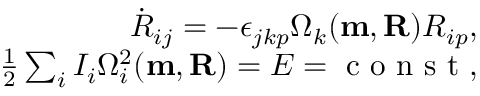Convert formula to latex. <formula><loc_0><loc_0><loc_500><loc_500>\begin{array} { r } { \dot { R } _ { i j } = - \epsilon _ { j k p } \Omega _ { k } ( { m , R } ) R _ { i p } , } \\ { \frac { 1 } { 2 } \sum _ { i } I _ { i } \Omega _ { i } ^ { 2 } ( { m , R } ) = E = c o n s t , } \end{array}</formula> 